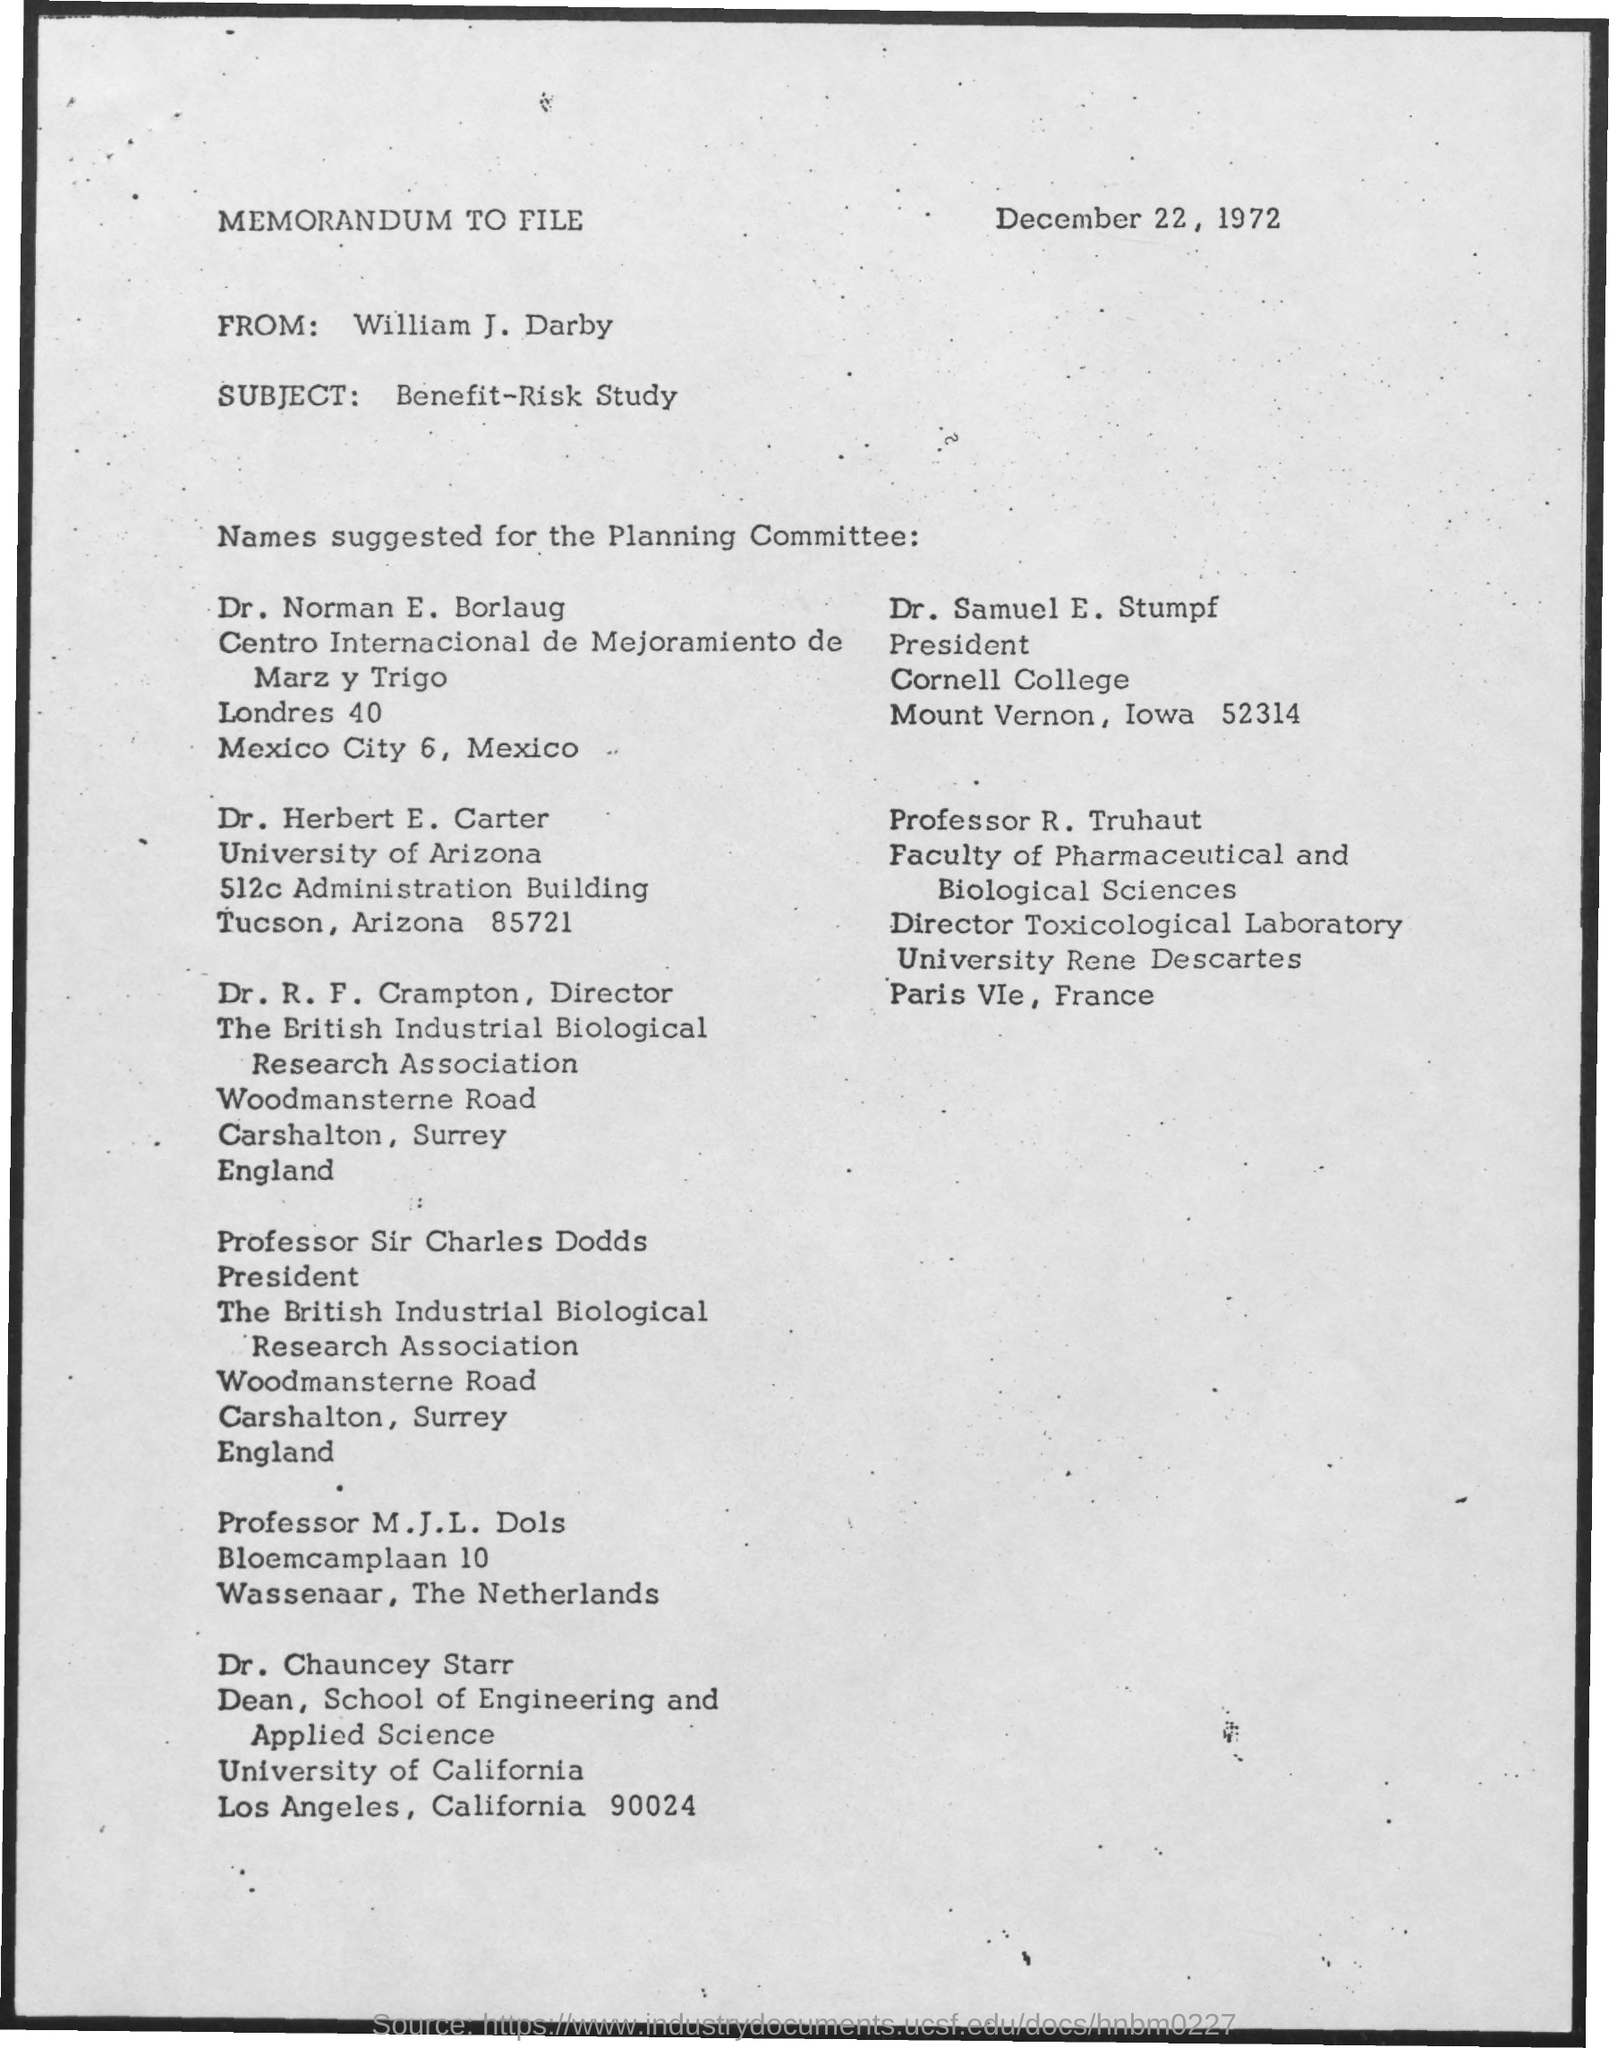Highlight a few significant elements in this photo. Cornell College is located in Mount Vernon, Iowa. The date mentioned is December 22, 1972. Dr. Samuel E. Stumpf is the current president of Cornell College. 